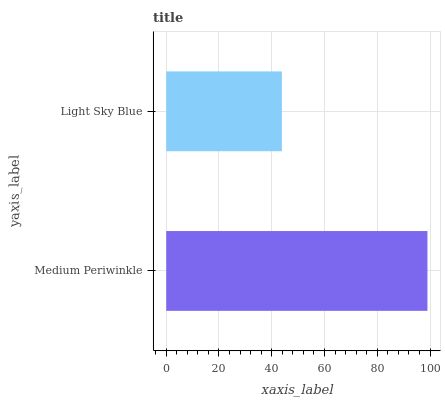Is Light Sky Blue the minimum?
Answer yes or no. Yes. Is Medium Periwinkle the maximum?
Answer yes or no. Yes. Is Light Sky Blue the maximum?
Answer yes or no. No. Is Medium Periwinkle greater than Light Sky Blue?
Answer yes or no. Yes. Is Light Sky Blue less than Medium Periwinkle?
Answer yes or no. Yes. Is Light Sky Blue greater than Medium Periwinkle?
Answer yes or no. No. Is Medium Periwinkle less than Light Sky Blue?
Answer yes or no. No. Is Medium Periwinkle the high median?
Answer yes or no. Yes. Is Light Sky Blue the low median?
Answer yes or no. Yes. Is Light Sky Blue the high median?
Answer yes or no. No. Is Medium Periwinkle the low median?
Answer yes or no. No. 